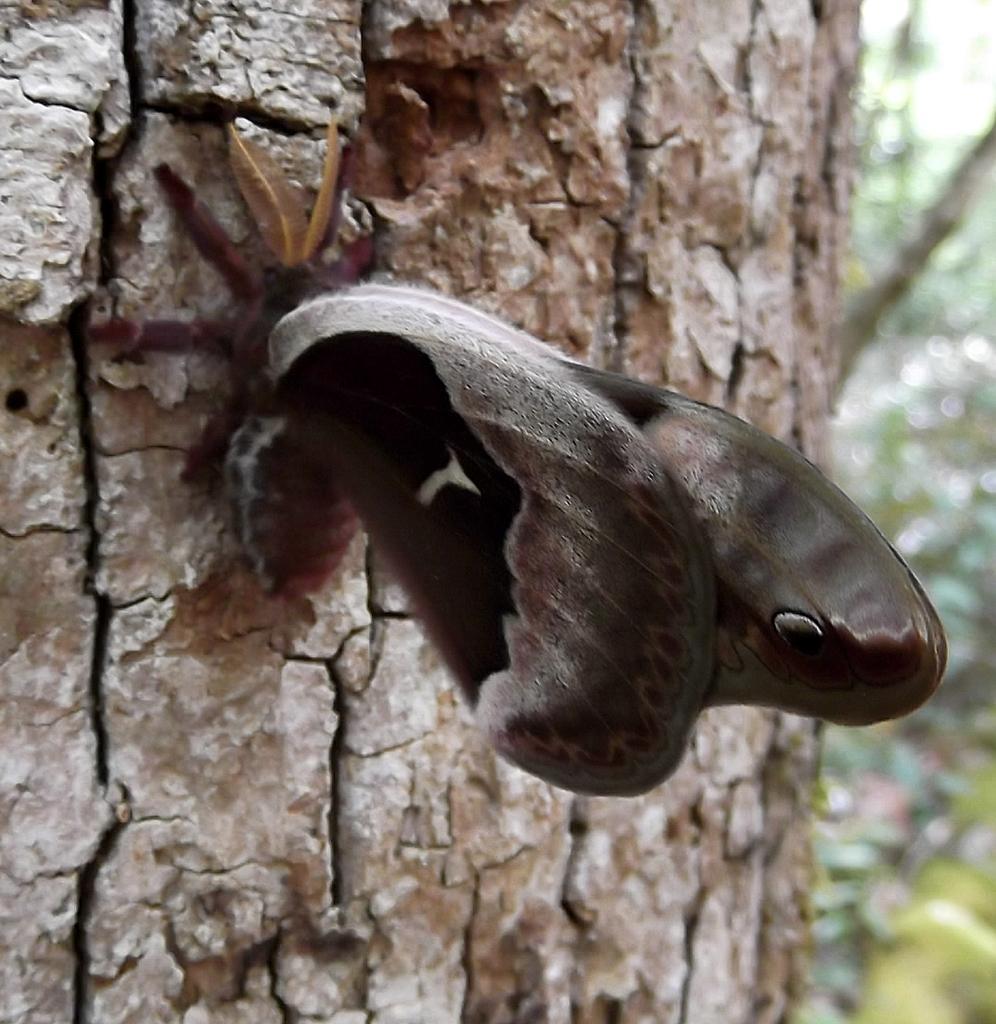Could you give a brief overview of what you see in this image? Here in this picture we can see a butterfly represent on the trunk of the tree over there. 